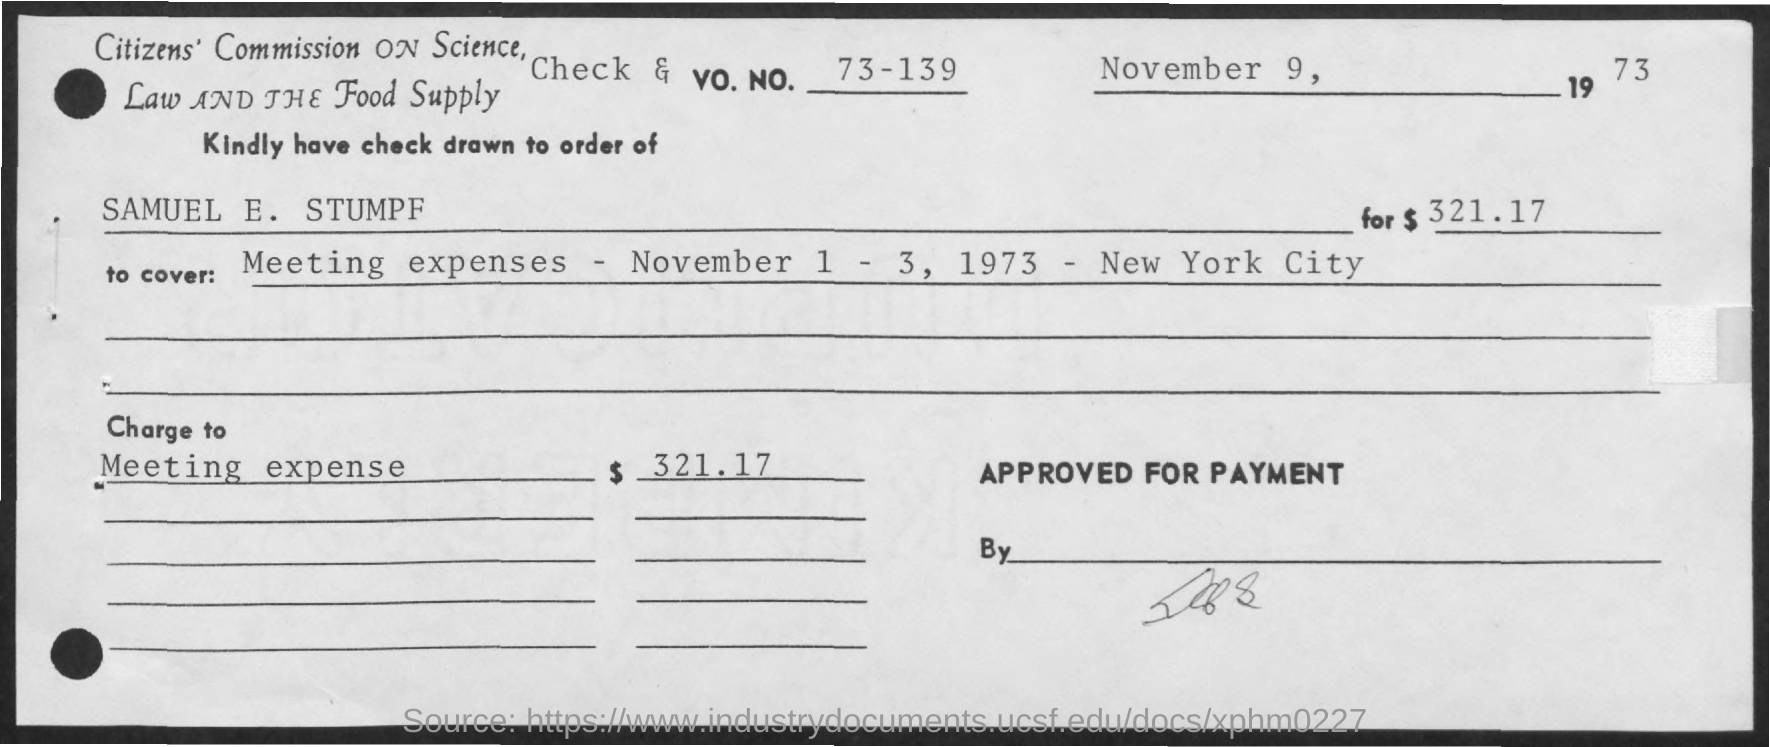Outline some significant characteristics in this image. The Vo. No. mentioned in the check is 73-139. This check covers the expenses incurred for a meeting that took place from November 1st to 3rd, 1973, in New York City. The date of the check is November 9, 1973. The amount of the check issued is $321.17. The check is being issued in the name of Samuel E. Stumpf, 